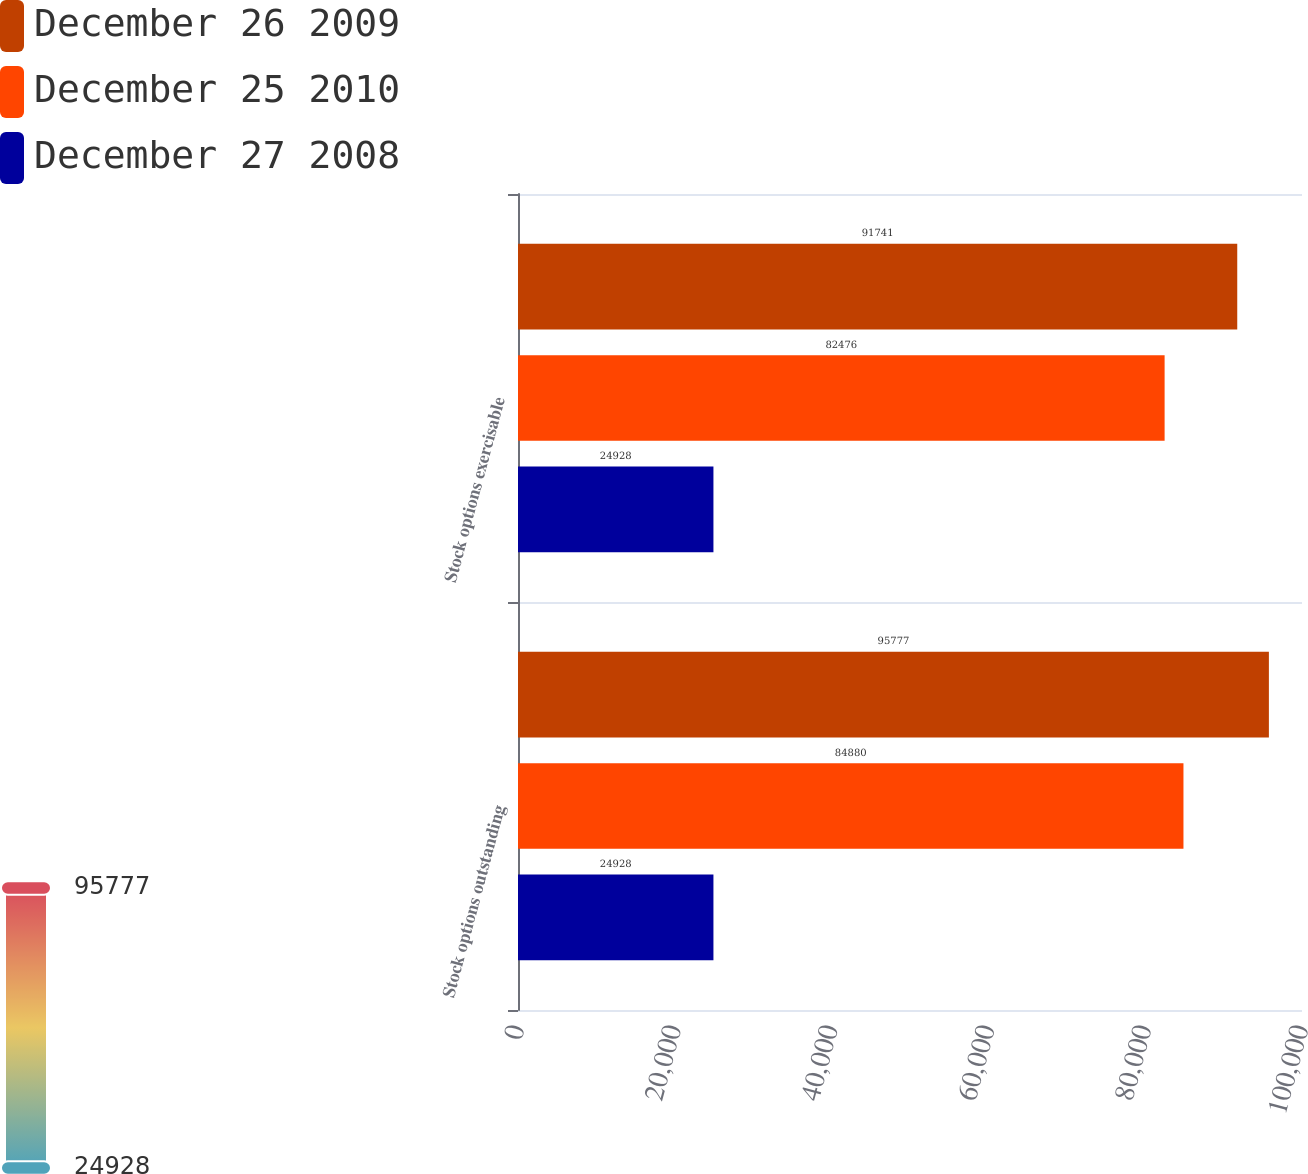<chart> <loc_0><loc_0><loc_500><loc_500><stacked_bar_chart><ecel><fcel>Stock options outstanding<fcel>Stock options exercisable<nl><fcel>December 26 2009<fcel>95777<fcel>91741<nl><fcel>December 25 2010<fcel>84880<fcel>82476<nl><fcel>December 27 2008<fcel>24928<fcel>24928<nl></chart> 